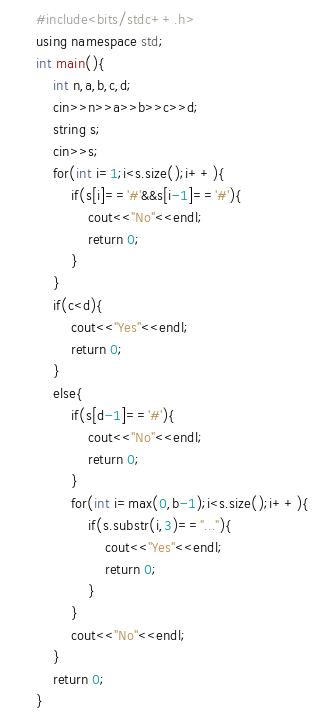<code> <loc_0><loc_0><loc_500><loc_500><_C++_>#include<bits/stdc++.h>
using namespace std;
int main(){
	int n,a,b,c,d;
	cin>>n>>a>>b>>c>>d;
	string s;
	cin>>s;
	for(int i=1;i<s.size();i++){
		if(s[i]=='#'&&s[i-1]=='#'){
			cout<<"No"<<endl;
			return 0;
		}
	}
	if(c<d){
		cout<<"Yes"<<endl;
		return 0;
	}
	else{
		if(s[d-1]=='#'){
			cout<<"No"<<endl;
			return 0;
		}
		for(int i=max(0,b-1);i<s.size();i++){
			if(s.substr(i,3)=="..."){
				cout<<"Yes"<<endl;
				return 0;
			}
		}
		cout<<"No"<<endl;
	}
	return 0;
}</code> 